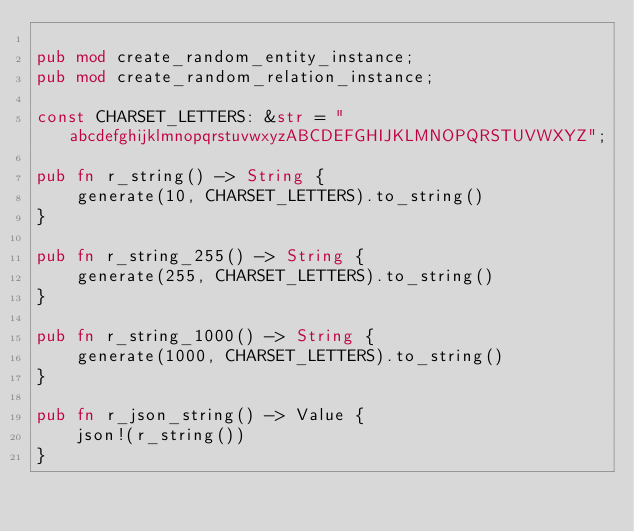Convert code to text. <code><loc_0><loc_0><loc_500><loc_500><_Rust_>
pub mod create_random_entity_instance;
pub mod create_random_relation_instance;

const CHARSET_LETTERS: &str = "abcdefghijklmnopqrstuvwxyzABCDEFGHIJKLMNOPQRSTUVWXYZ";

pub fn r_string() -> String {
    generate(10, CHARSET_LETTERS).to_string()
}

pub fn r_string_255() -> String {
    generate(255, CHARSET_LETTERS).to_string()
}

pub fn r_string_1000() -> String {
    generate(1000, CHARSET_LETTERS).to_string()
}

pub fn r_json_string() -> Value {
    json!(r_string())
}
</code> 